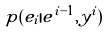Convert formula to latex. <formula><loc_0><loc_0><loc_500><loc_500>p ( e _ { i } | e ^ { i - 1 } , y ^ { i } )</formula> 